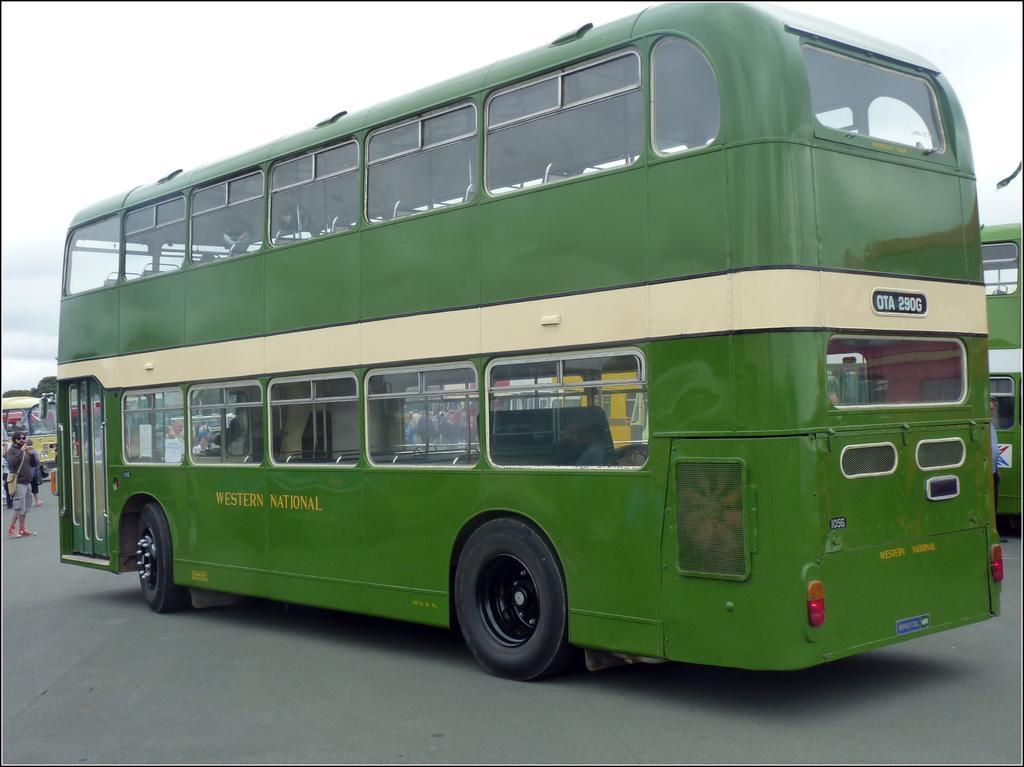Could you give a brief overview of what you see in this image? In this picture there is a bus in the center of the image and there is a man on the left side of the image. 